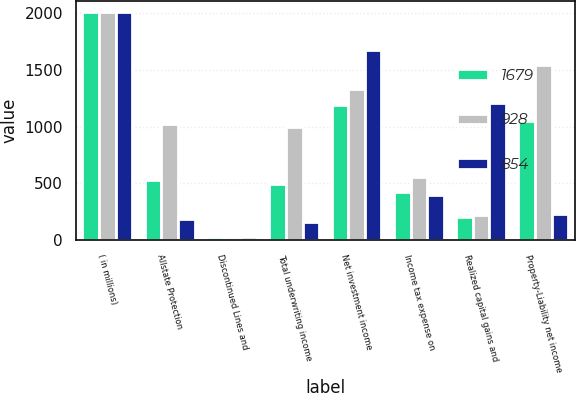Convert chart to OTSL. <chart><loc_0><loc_0><loc_500><loc_500><stacked_bar_chart><ecel><fcel>( in millions)<fcel>Allstate Protection<fcel>Discontinued Lines and<fcel>Total underwriting income<fcel>Net investment income<fcel>Income tax expense on<fcel>Realized capital gains and<fcel>Property-Liability net income<nl><fcel>1679<fcel>2010<fcel>526<fcel>31<fcel>495<fcel>1189<fcel>426<fcel>207<fcel>1054<nl><fcel>928<fcel>2009<fcel>1027<fcel>32<fcel>995<fcel>1328<fcel>558<fcel>222<fcel>1543<nl><fcel>854<fcel>2008<fcel>189<fcel>25<fcel>164<fcel>1674<fcel>401<fcel>1209<fcel>228<nl></chart> 